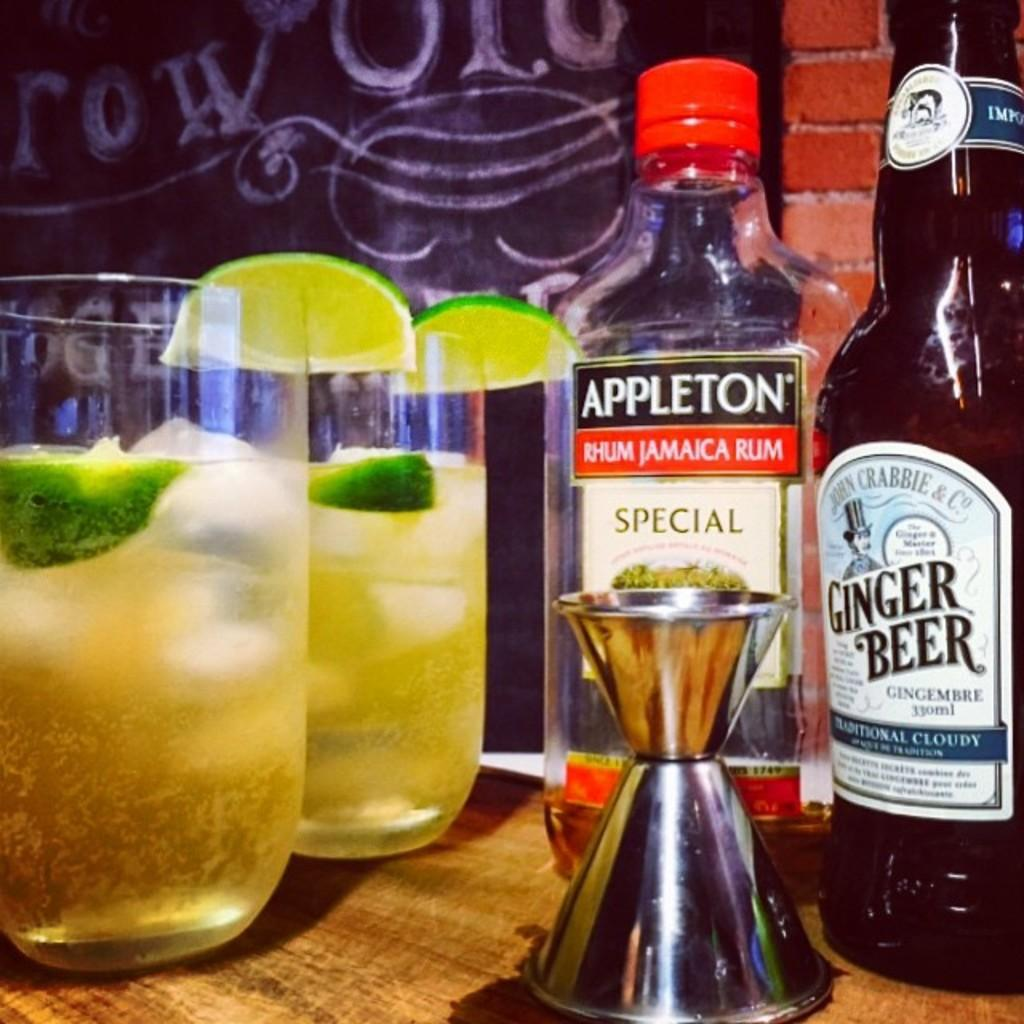<image>
Share a concise interpretation of the image provided. A bottle of ginger beeter, a bottle of Appleton Jamaica rum, a jigger, and two cocktails with lime garnishes. 